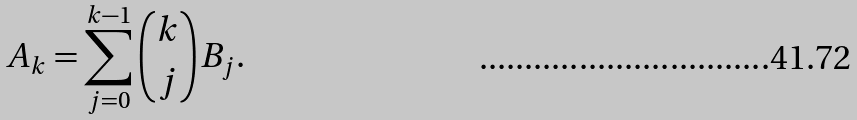Convert formula to latex. <formula><loc_0><loc_0><loc_500><loc_500>A _ { k } = \sum _ { j = 0 } ^ { k - 1 } \binom { k } { j } B _ { j } .</formula> 